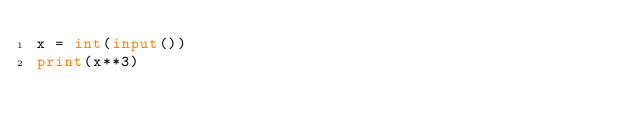Convert code to text. <code><loc_0><loc_0><loc_500><loc_500><_Python_>x = int(input())
print(x**3)
</code> 